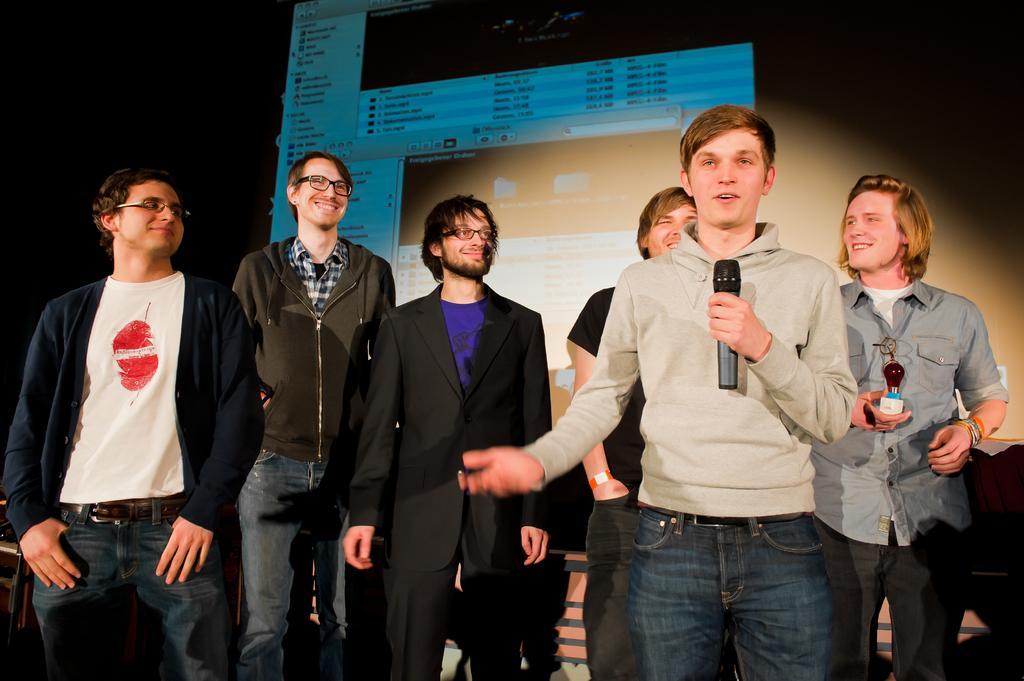Please provide a concise description of this image. In this image we can see a few people standing and among them one person holding a mic and talking and in the background, we can see a screen with some picture. 